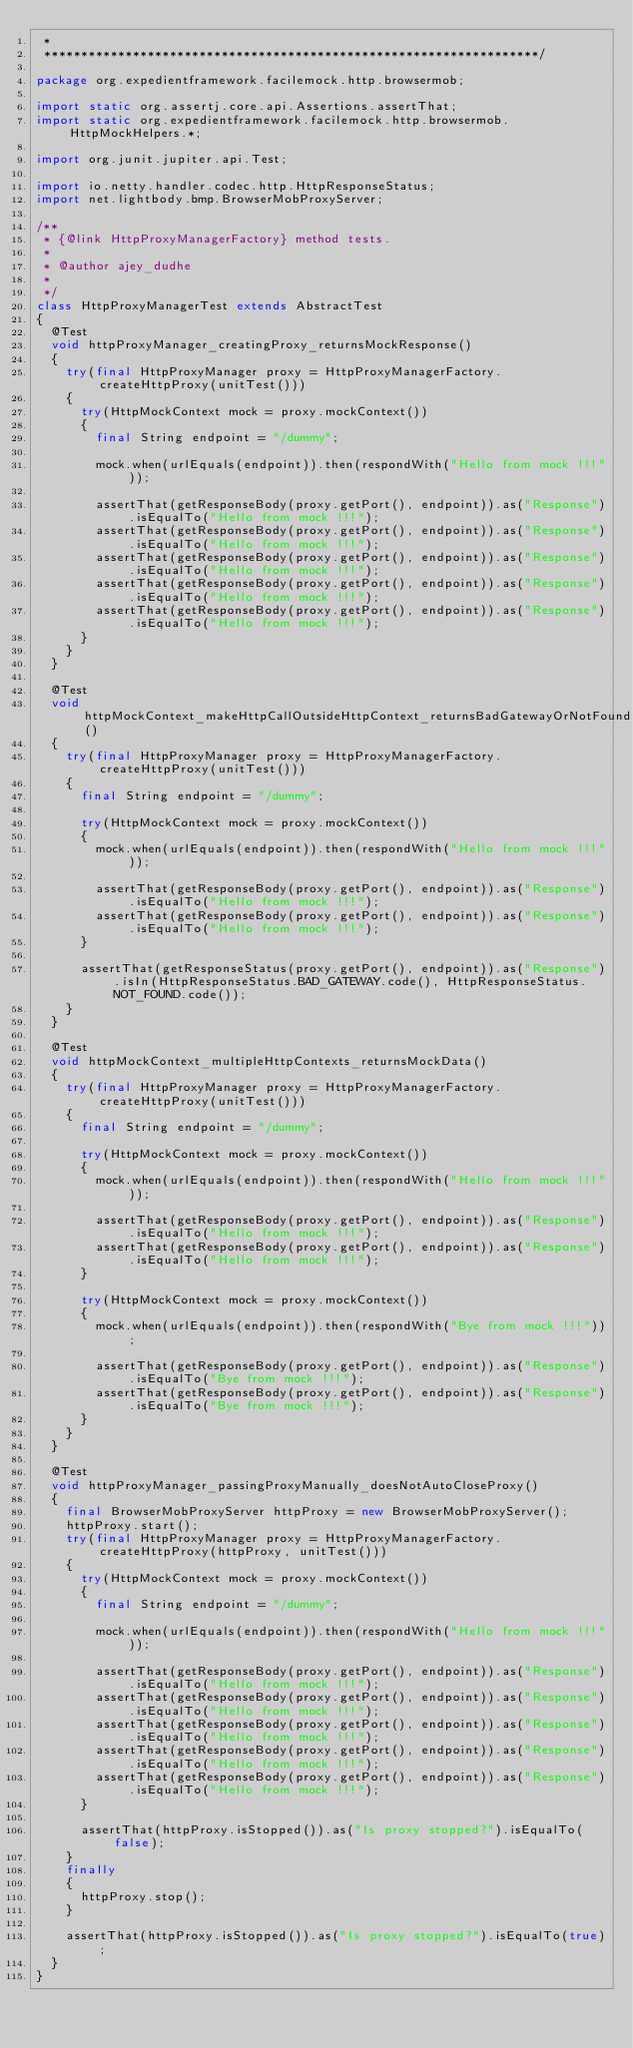<code> <loc_0><loc_0><loc_500><loc_500><_Java_> *
 *******************************************************************/

package org.expedientframework.facilemock.http.browsermob;

import static org.assertj.core.api.Assertions.assertThat;
import static org.expedientframework.facilemock.http.browsermob.HttpMockHelpers.*;

import org.junit.jupiter.api.Test;

import io.netty.handler.codec.http.HttpResponseStatus;
import net.lightbody.bmp.BrowserMobProxyServer;

/**
 * {@link HttpProxyManagerFactory} method tests.
 * 
 * @author ajey_dudhe
 *
 */
class HttpProxyManagerTest extends AbstractTest
{
  @Test
  void httpProxyManager_creatingProxy_returnsMockResponse()
  {
    try(final HttpProxyManager proxy = HttpProxyManagerFactory.createHttpProxy(unitTest()))
    {
      try(HttpMockContext mock = proxy.mockContext())
      {
        final String endpoint = "/dummy";
        
        mock.when(urlEquals(endpoint)).then(respondWith("Hello from mock !!!"));
        
        assertThat(getResponseBody(proxy.getPort(), endpoint)).as("Response").isEqualTo("Hello from mock !!!");
        assertThat(getResponseBody(proxy.getPort(), endpoint)).as("Response").isEqualTo("Hello from mock !!!");
        assertThat(getResponseBody(proxy.getPort(), endpoint)).as("Response").isEqualTo("Hello from mock !!!");
        assertThat(getResponseBody(proxy.getPort(), endpoint)).as("Response").isEqualTo("Hello from mock !!!");
        assertThat(getResponseBody(proxy.getPort(), endpoint)).as("Response").isEqualTo("Hello from mock !!!");
      }
    }
  }
  
  @Test
  void httpMockContext_makeHttpCallOutsideHttpContext_returnsBadGatewayOrNotFound()
  {
    try(final HttpProxyManager proxy = HttpProxyManagerFactory.createHttpProxy(unitTest()))
    {
      final String endpoint = "/dummy";
      
      try(HttpMockContext mock = proxy.mockContext())
      {
        mock.when(urlEquals(endpoint)).then(respondWith("Hello from mock !!!"));
        
        assertThat(getResponseBody(proxy.getPort(), endpoint)).as("Response").isEqualTo("Hello from mock !!!");
        assertThat(getResponseBody(proxy.getPort(), endpoint)).as("Response").isEqualTo("Hello from mock !!!");
      }
      
      assertThat(getResponseStatus(proxy.getPort(), endpoint)).as("Response").isIn(HttpResponseStatus.BAD_GATEWAY.code(), HttpResponseStatus.NOT_FOUND.code());
    }
  }

  @Test
  void httpMockContext_multipleHttpContexts_returnsMockData()
  {
    try(final HttpProxyManager proxy = HttpProxyManagerFactory.createHttpProxy(unitTest()))
    {
      final String endpoint = "/dummy";
      
      try(HttpMockContext mock = proxy.mockContext())
      {
        mock.when(urlEquals(endpoint)).then(respondWith("Hello from mock !!!"));
        
        assertThat(getResponseBody(proxy.getPort(), endpoint)).as("Response").isEqualTo("Hello from mock !!!");
        assertThat(getResponseBody(proxy.getPort(), endpoint)).as("Response").isEqualTo("Hello from mock !!!");
      }
      
      try(HttpMockContext mock = proxy.mockContext())
      {
        mock.when(urlEquals(endpoint)).then(respondWith("Bye from mock !!!"));
        
        assertThat(getResponseBody(proxy.getPort(), endpoint)).as("Response").isEqualTo("Bye from mock !!!");
        assertThat(getResponseBody(proxy.getPort(), endpoint)).as("Response").isEqualTo("Bye from mock !!!");
      }
    }
  }

  @Test
  void httpProxyManager_passingProxyManually_doesNotAutoCloseProxy()
  {
    final BrowserMobProxyServer httpProxy = new BrowserMobProxyServer();
    httpProxy.start();
    try(final HttpProxyManager proxy = HttpProxyManagerFactory.createHttpProxy(httpProxy, unitTest()))
    {
      try(HttpMockContext mock = proxy.mockContext())
      {
        final String endpoint = "/dummy";
        
        mock.when(urlEquals(endpoint)).then(respondWith("Hello from mock !!!"));
        
        assertThat(getResponseBody(proxy.getPort(), endpoint)).as("Response").isEqualTo("Hello from mock !!!");
        assertThat(getResponseBody(proxy.getPort(), endpoint)).as("Response").isEqualTo("Hello from mock !!!");
        assertThat(getResponseBody(proxy.getPort(), endpoint)).as("Response").isEqualTo("Hello from mock !!!");
        assertThat(getResponseBody(proxy.getPort(), endpoint)).as("Response").isEqualTo("Hello from mock !!!");
        assertThat(getResponseBody(proxy.getPort(), endpoint)).as("Response").isEqualTo("Hello from mock !!!");
      }
      
      assertThat(httpProxy.isStopped()).as("Is proxy stopped?").isEqualTo(false);
    }
    finally
    {
      httpProxy.stop();
    }

    assertThat(httpProxy.isStopped()).as("Is proxy stopped?").isEqualTo(true);
  }  
}

</code> 